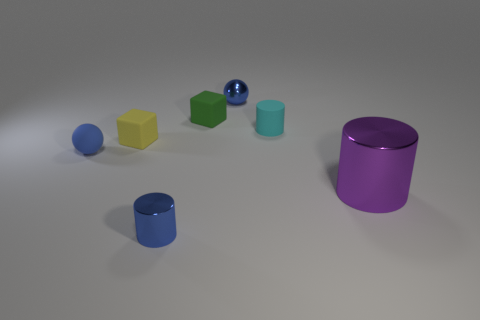There is a tiny metal ball; is its color the same as the tiny matte thing that is in front of the yellow block?
Provide a short and direct response. Yes. There is a rubber object that is left of the yellow block; is it the same shape as the tiny blue metal object that is in front of the tiny yellow rubber object?
Keep it short and to the point. No. Do the blue cylinder and the cylinder on the right side of the small cyan rubber cylinder have the same size?
Provide a short and direct response. No. What is the shape of the purple metal object?
Your answer should be compact. Cylinder. What number of matte objects have the same color as the shiny ball?
Provide a short and direct response. 1. What is the color of the other tiny object that is the same shape as the small green rubber thing?
Provide a succinct answer. Yellow. How many small rubber balls are behind the tiny rubber object behind the cyan rubber cylinder?
Offer a terse response. 0. What number of spheres are either green matte objects or blue shiny things?
Offer a terse response. 1. Is there a green cube?
Provide a succinct answer. Yes. There is another thing that is the same shape as the tiny yellow matte object; what is its size?
Your response must be concise. Small. 